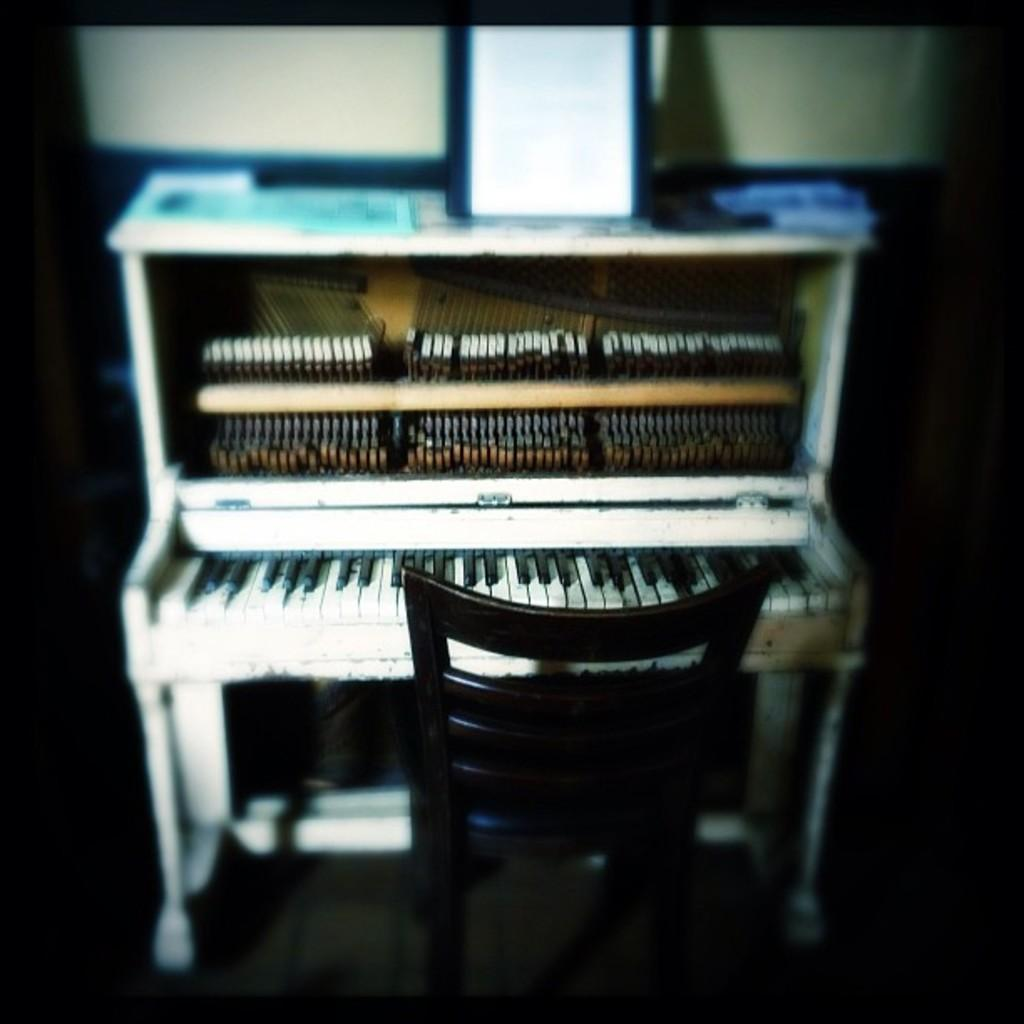What musical instrument is present in the image? There is a piano in the image. What type of furniture is in the image? There is a chair in the image. What object is used for holding books in the image? There is a book stand in the image. What type of badge is being worn by the person playing the piano in the image? There is no person present in the image, and therefore no badge can be observed. What type of pleasure is being derived from playing the piano in the image? The image does not convey any emotions or feelings, so it is impossible to determine the type of pleasure being derived from playing the piano. 